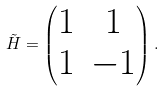<formula> <loc_0><loc_0><loc_500><loc_500>\tilde { H } = \begin{pmatrix} 1 & 1 \\ 1 & - 1 \end{pmatrix} .</formula> 